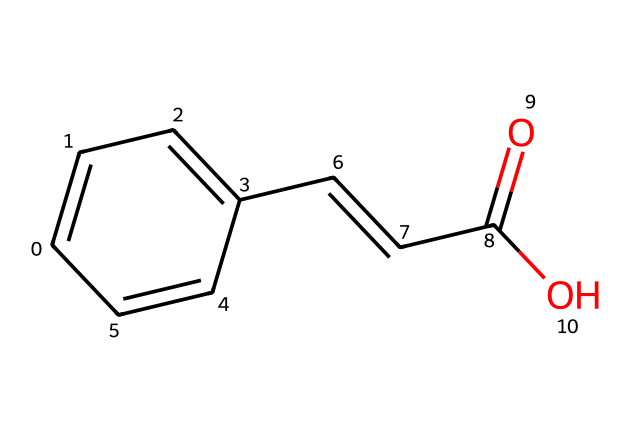What is the molecular formula of cinnamic acid? To derive the molecular formula, count the different types of atoms in the provided SMILES representation. Cinnamic acid has 9 carbon atoms (C), 8 hydrogen atoms (H), and 2 oxygen atoms (O). Thus, the molecular formula is C9H8O2.
Answer: C9H8O2 How many double bonds are present in cinnamic acid? Analyze the SMILES string and identify the double bonds denoted by "=". There are three double bonds in this molecule: one in the phenyl ring and two in the alkenyl chain.
Answer: 3 What is the stereochemistry of the E-Z isomers in cinnamic acid? The configuration around the double bond is determined by the substituents attached to the carbon atoms involved. In cinnamic acid, the two substituents (the carboxylic acid group and the other alkyl chain) are on opposite sides in the E configuration.
Answer: E How does conjugation affect the stability of cinnamic acid? Cinnamic acid exhibits conjugation between the double bonds and the aromatic ring, enhancing its stability due to delocalized pi electrons. This increased stability is often reflected in its reactivity and UV-Vis absorbance characteristics.
Answer: Increased stability What distinguishes E-Z isomers from each other? E-Z isomers differ in the spatial arrangement of groups attached to the double bond. The E isomer has higher priority groups on opposite sides, while the Z isomer has them on the same side. This difference in arrangement leads to varying physical and chemical properties.
Answer: Spatial arrangement In premium leather treatments, what role does cinnamic acid play? Cinnamic acid is used as a natural tanning agent, providing beneficial properties to leather, such as increased flexibility and durability while imparting a pleasing aesthetic finish.
Answer: Natural tanning agent 